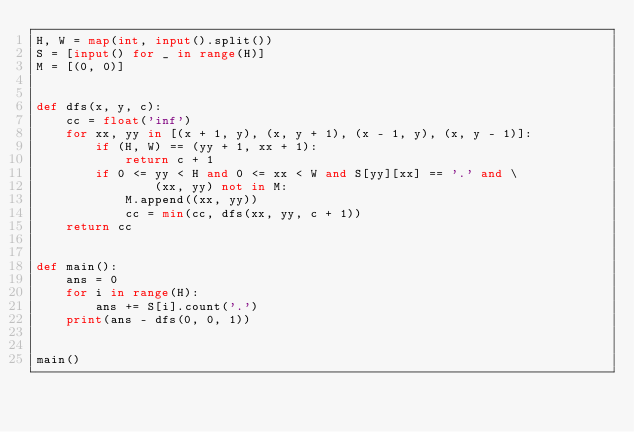<code> <loc_0><loc_0><loc_500><loc_500><_Python_>H, W = map(int, input().split())
S = [input() for _ in range(H)]
M = [(0, 0)]


def dfs(x, y, c):
    cc = float('inf')
    for xx, yy in [(x + 1, y), (x, y + 1), (x - 1, y), (x, y - 1)]:
        if (H, W) == (yy + 1, xx + 1):
            return c + 1
        if 0 <= yy < H and 0 <= xx < W and S[yy][xx] == '.' and \
                (xx, yy) not in M:
            M.append((xx, yy))
            cc = min(cc, dfs(xx, yy, c + 1))
    return cc


def main():
    ans = 0
    for i in range(H):
        ans += S[i].count('.')
    print(ans - dfs(0, 0, 1))


main()
</code> 